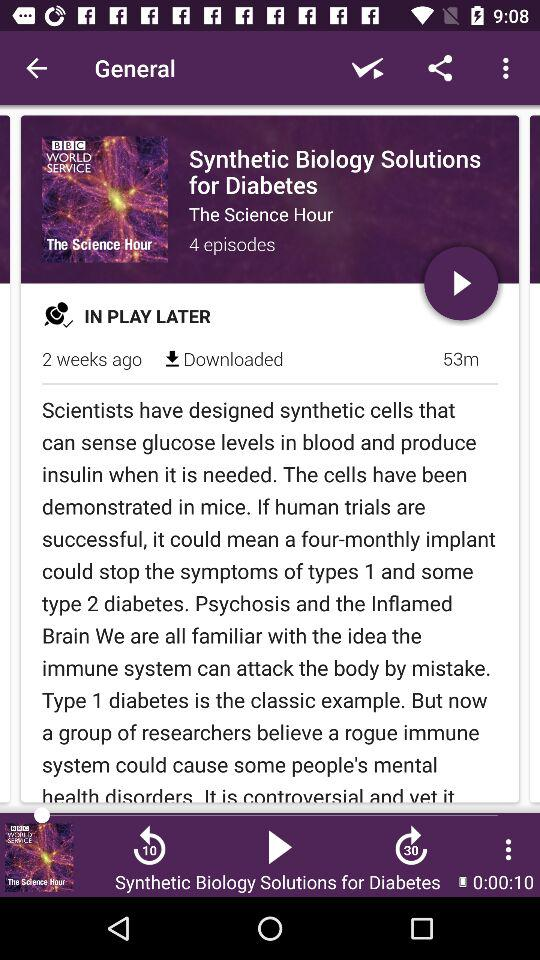How much of the video has been played? The video has been playing for 10 seconds. 